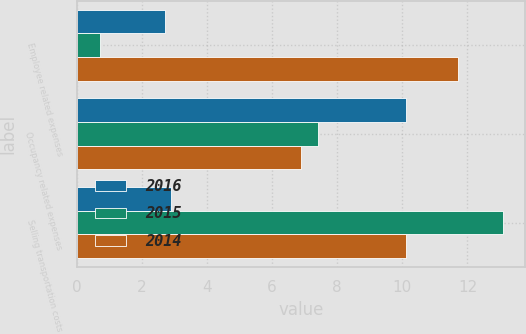Convert chart to OTSL. <chart><loc_0><loc_0><loc_500><loc_500><stacked_bar_chart><ecel><fcel>Employee related expenses<fcel>Occupancy related expenses<fcel>Selling transportation costs<nl><fcel>2016<fcel>2.7<fcel>10.1<fcel>2.9<nl><fcel>2015<fcel>0.7<fcel>7.4<fcel>13.1<nl><fcel>2014<fcel>11.7<fcel>6.9<fcel>10.1<nl></chart> 